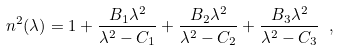Convert formula to latex. <formula><loc_0><loc_0><loc_500><loc_500>n ^ { 2 } ( \lambda ) = 1 + \frac { B _ { 1 } \lambda ^ { 2 } } { \lambda ^ { 2 } - C _ { 1 } } + \frac { B _ { 2 } \lambda ^ { 2 } } { \lambda ^ { 2 } - C _ { 2 } } + \frac { B _ { 3 } \lambda ^ { 2 } } { \lambda ^ { 2 } - C _ { 3 } } \ ,</formula> 